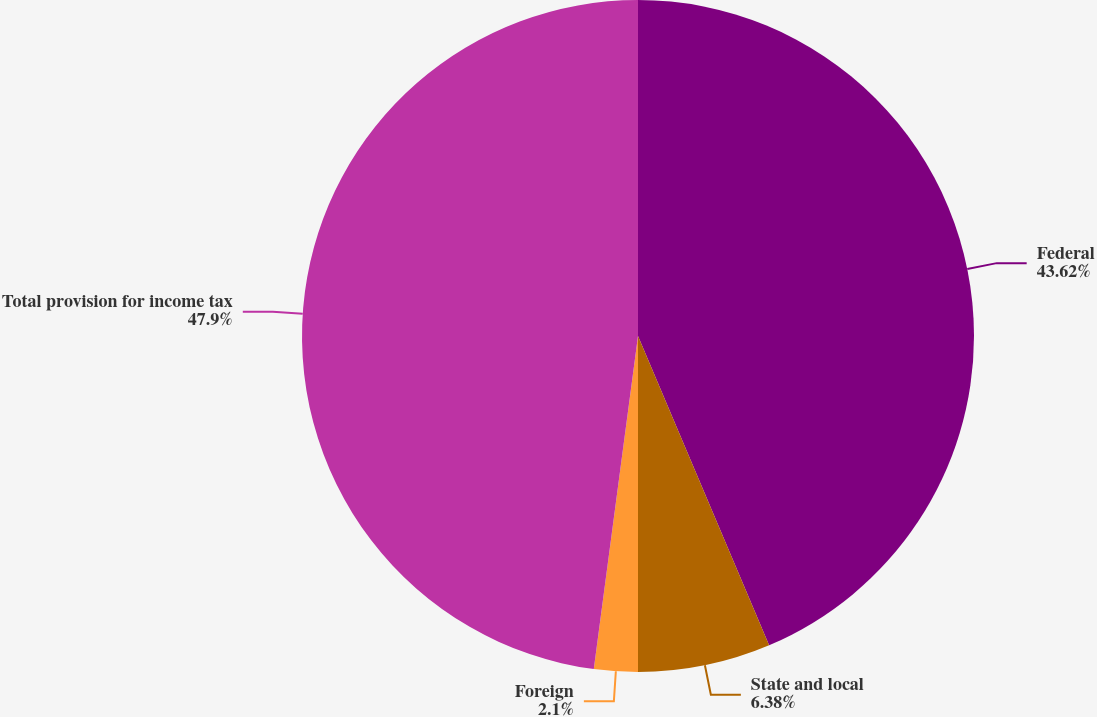Convert chart to OTSL. <chart><loc_0><loc_0><loc_500><loc_500><pie_chart><fcel>Federal<fcel>State and local<fcel>Foreign<fcel>Total provision for income tax<nl><fcel>43.62%<fcel>6.38%<fcel>2.1%<fcel>47.9%<nl></chart> 